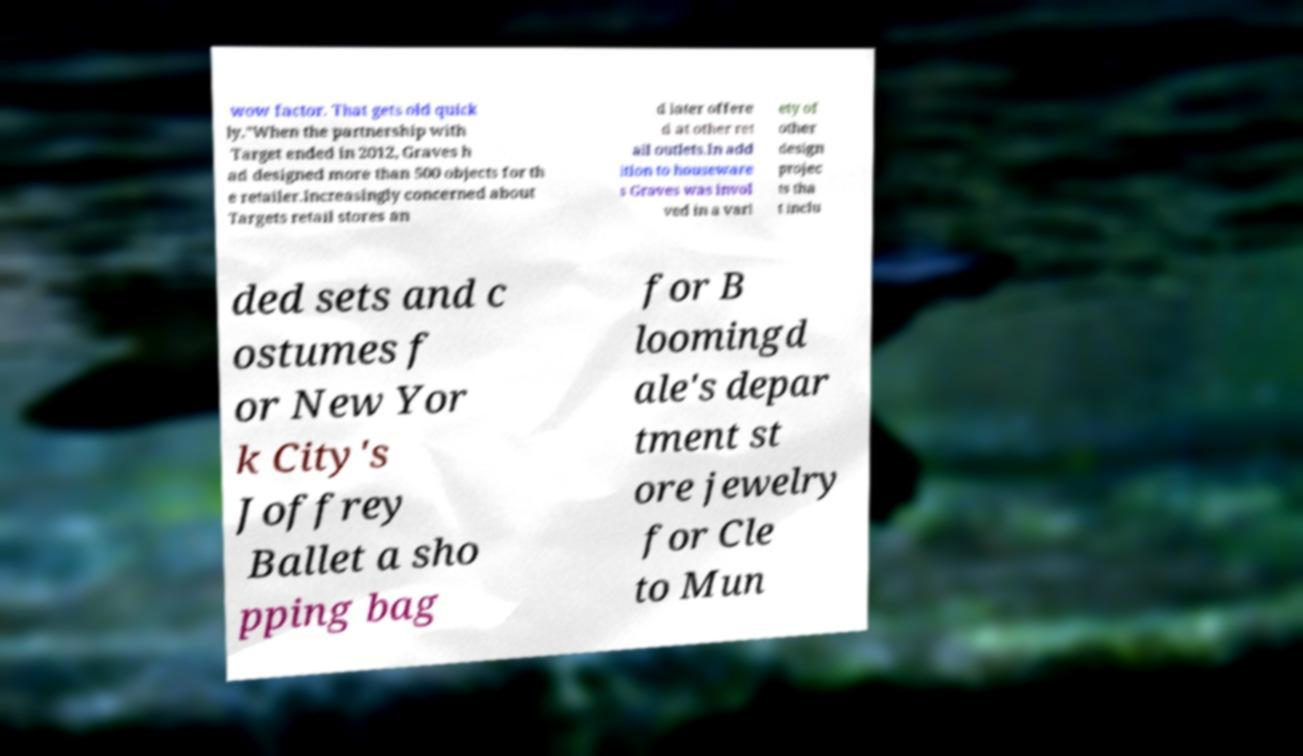There's text embedded in this image that I need extracted. Can you transcribe it verbatim? wow factor. That gets old quick ly."When the partnership with Target ended in 2012, Graves h ad designed more than 500 objects for th e retailer.Increasingly concerned about Targets retail stores an d later offere d at other ret ail outlets.In add ition to houseware s Graves was invol ved in a vari ety of other design projec ts tha t inclu ded sets and c ostumes f or New Yor k City's Joffrey Ballet a sho pping bag for B loomingd ale's depar tment st ore jewelry for Cle to Mun 